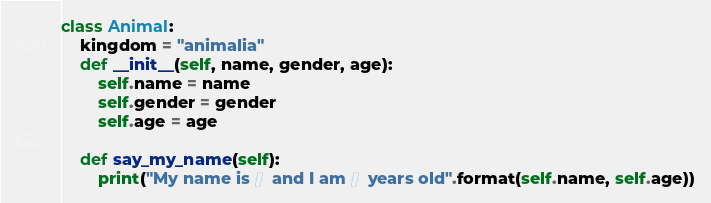<code> <loc_0><loc_0><loc_500><loc_500><_Python_>class Animal:
    kingdom = "animalia"
    def __init__(self, name, gender, age):
        self.name = name
        self.gender = gender
        self.age = age

    def say_my_name(self):
        print("My name is {} and I am {} years old".format(self.name, self.age))
</code> 